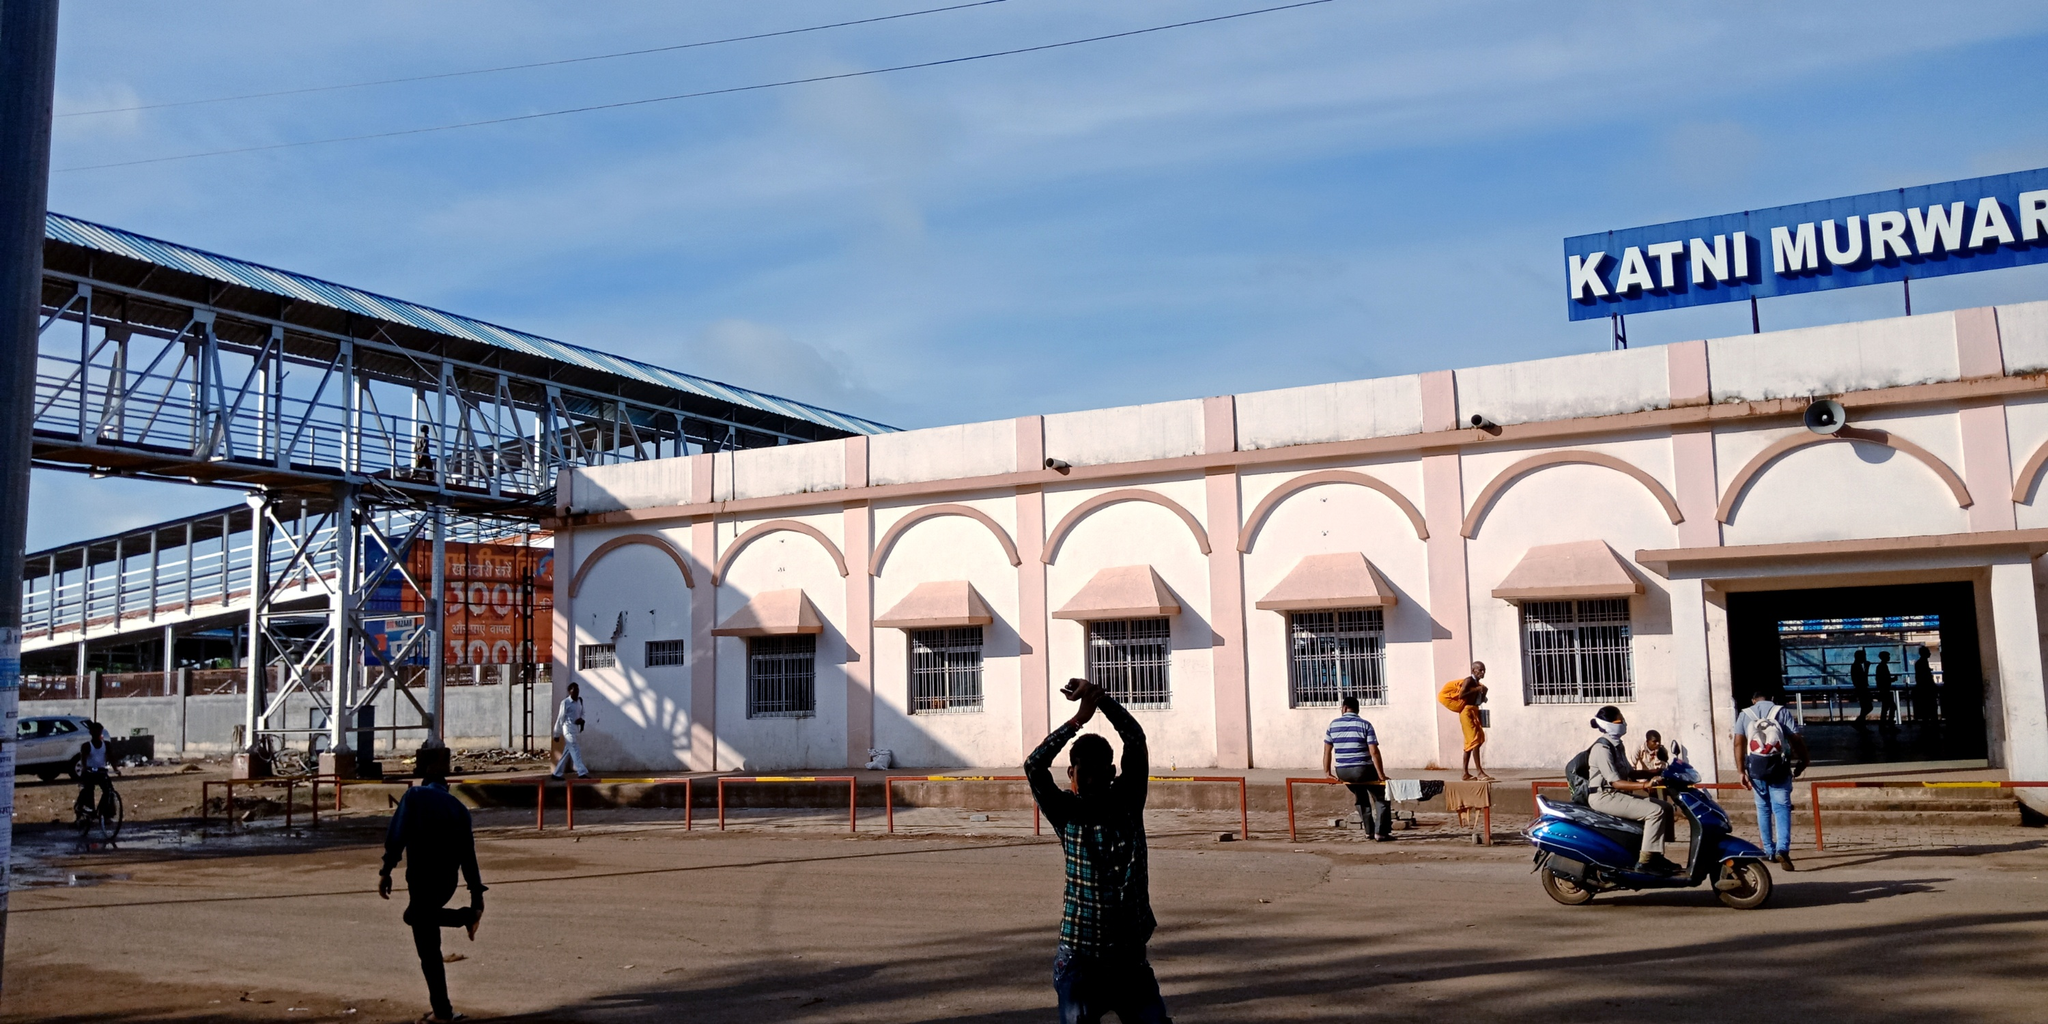What are the key elements in this picture?
 The image captures a lively scene at the Katni Murwara railway station in India. The station itself is a charming white building adorned with pink arches, and its name, "Katni Murwara", is displayed prominently in blue letters. 

A handful of people are scattered around the exterior of the station, adding a sense of activity to the scene. Among them, a man in a green shirt stands out as he is in the midst of capturing a photo with his phone. His action suggests that there's something noteworthy happening, or perhaps he's simply documenting his journey.

On the right side of the photo, a blue scooter is parked, possibly belonging to one of the travelers or a local resident. Its presence adds a touch of everyday life to the scene.

Above all this, the sky stretches out in a clear blue, with a few clouds dotting the expanse, suggesting a pleasant day for travel. The precise locations of the objects and their interactions paint a vivid picture of a typical day at the Katni Murwara railway station. 